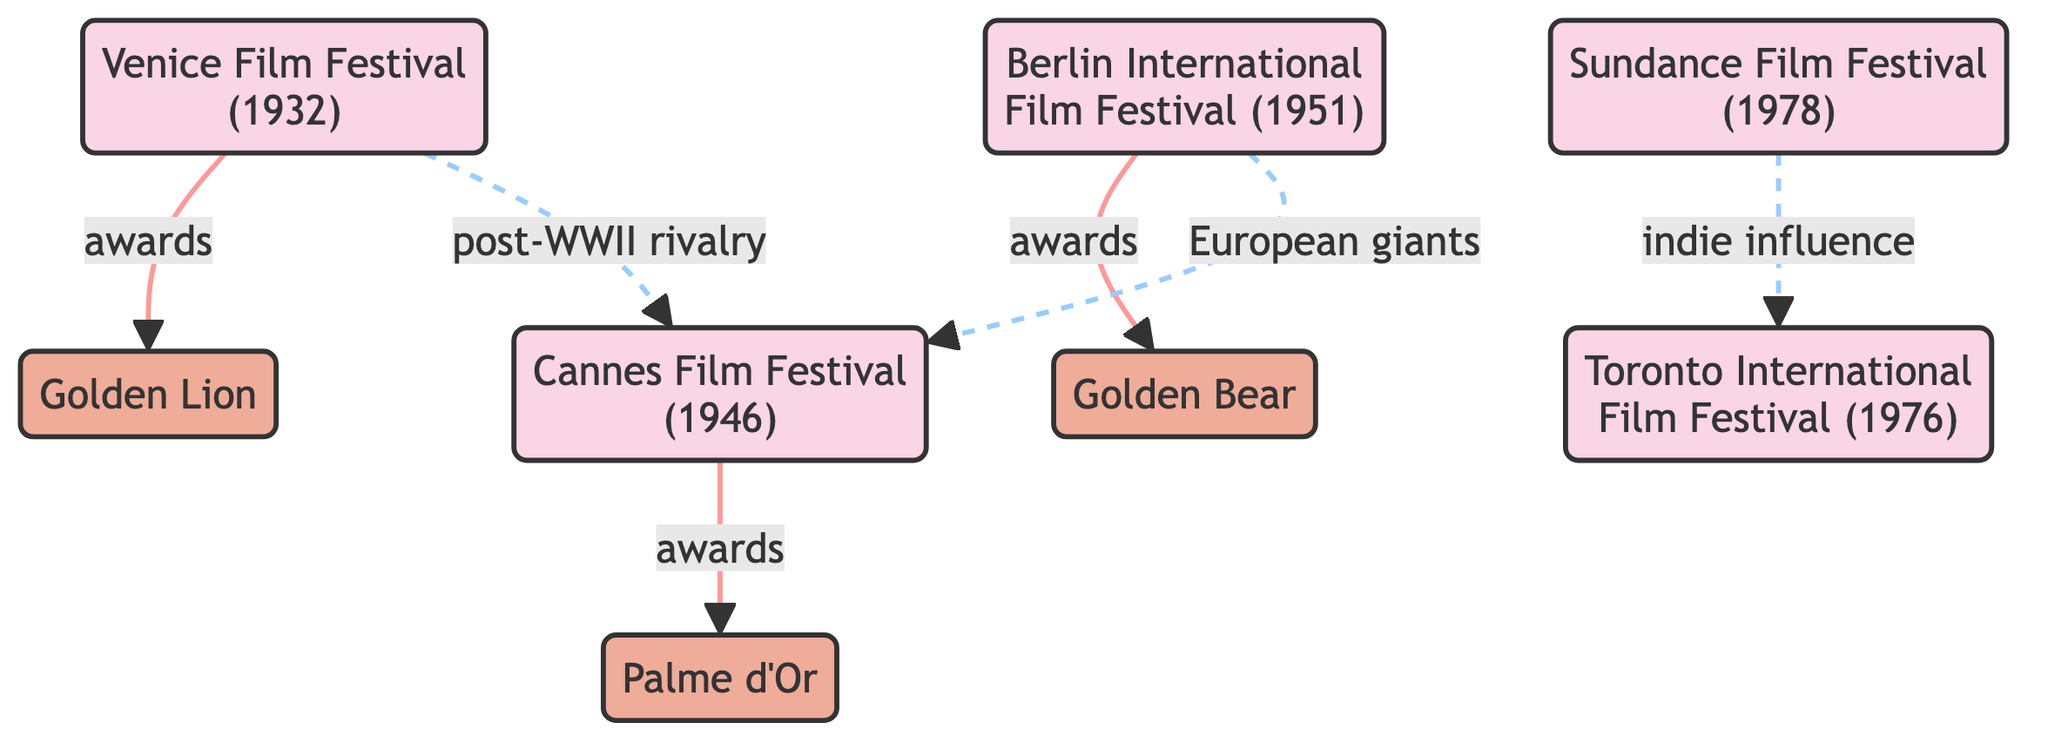What year was the Cannes Film Festival established? The diagram indicates the Cannes Film Festival node, which clearly states its establishment year as 1946.
Answer: 1946 What is the award given at the Venice Film Festival? The Venice node connects to the Golden Lion node, indicating that the award given at this festival is the Golden Lion.
Answer: Golden Lion How many major film festivals are represented in the diagram? By counting the festival nodes in the diagram, there are five major festivals: Cannes, Venice, Berlin, Sundance, and TIFF.
Answer: 5 Which festival is associated with the award called Golden Bear? The Berlin Festival node connects to the Berlinale award node, indicating that the Golden Bear is awarded at the Berlin International Film Festival.
Answer: Berlin What type of influence does Sundance have on TIFF? The diagram indicates a dashed line going from Sundance to TIFF labeled "indie influence," indicating a specific kind of influence they have on each other.
Answer: indie influence Which festival has a post-WWII rivalry with Cannes? The Venice node is linked with a dashed line labeled "post-WWII rivalry," indicating that Venice has this rivalry with Cannes.
Answer: Venice In which year was the Sundance Film Festival founded? The Sundance Film Festival node highlights its founding year as 1978, providing the necessary information directly in the diagram.
Answer: 1978 What color is used to represent film festival nodes in the diagram? The festival nodes are colored with a fill of #f9d5e5 as specified in the class definition for the festival nodes in the diagram.
Answer: Pink Which festival is the oldest according to the diagram? By examining the establishment years noted by the nodes, the Venice Film Festival (established in 1932) is the oldest among the festivals listed.
Answer: Venice 